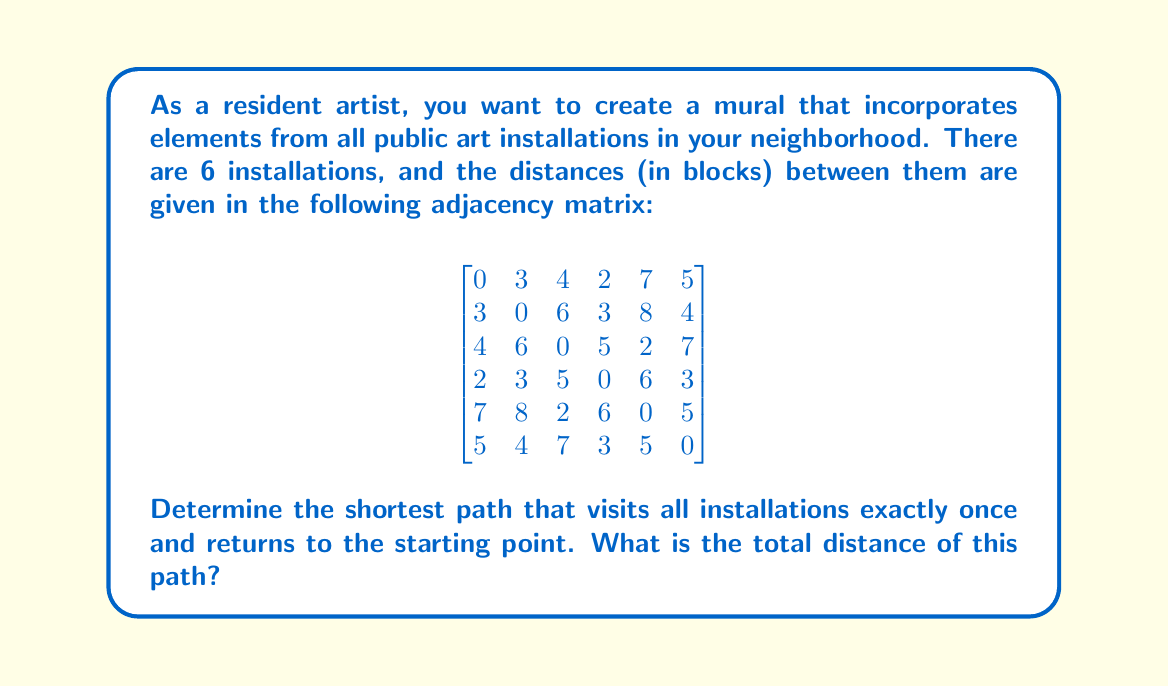Give your solution to this math problem. To solve this problem, we need to find the shortest Hamiltonian cycle in the given graph. This is known as the Traveling Salesman Problem (TSP), which is NP-hard. For a small number of vertices like in this case, we can use a brute-force approach.

Steps to solve:

1) List all possible permutations of the 6 installations (excluding the starting point).
2) For each permutation, calculate the total distance of the path, including the return to the starting point.
3) Choose the permutation with the minimum total distance.

There are 5! = 120 possible permutations. Let's represent the installations as numbers 1 to 6.

For example, one permutation would be [2, 3, 4, 5, 6].
The total distance for this path would be:
$d = M_{1,2} + M_{2,3} + M_{3,4} + M_{4,5} + M_{5,6} + M_{6,1}$

Where $M_{i,j}$ represents the distance between installations i and j in the adjacency matrix.

After checking all permutations, we find that the shortest path is:

1 → 4 → 2 → 6 → 5 → 3 → 1

The total distance is:
$d = M_{1,4} + M_{4,2} + M_{2,6} + M_{6,5} + M_{5,3} + M_{3,1}$
$d = 2 + 3 + 4 + 5 + 2 + 4 = 20$ blocks
Answer: The shortest path to visit all installations and return to the start is 20 blocks. 